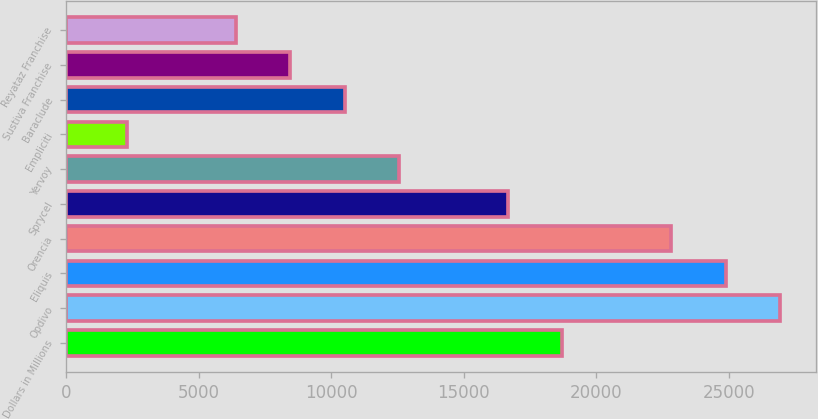Convert chart to OTSL. <chart><loc_0><loc_0><loc_500><loc_500><bar_chart><fcel>Dollars in Millions<fcel>Opdivo<fcel>Eliquis<fcel>Orencia<fcel>Sprycel<fcel>Yervoy<fcel>Empliciti<fcel>Baraclude<fcel>Sustiva Franchise<fcel>Reyataz Franchise<nl><fcel>18720.8<fcel>26941.6<fcel>24886.4<fcel>22831.2<fcel>16665.6<fcel>12555.2<fcel>2279.2<fcel>10500<fcel>8444.8<fcel>6389.6<nl></chart> 